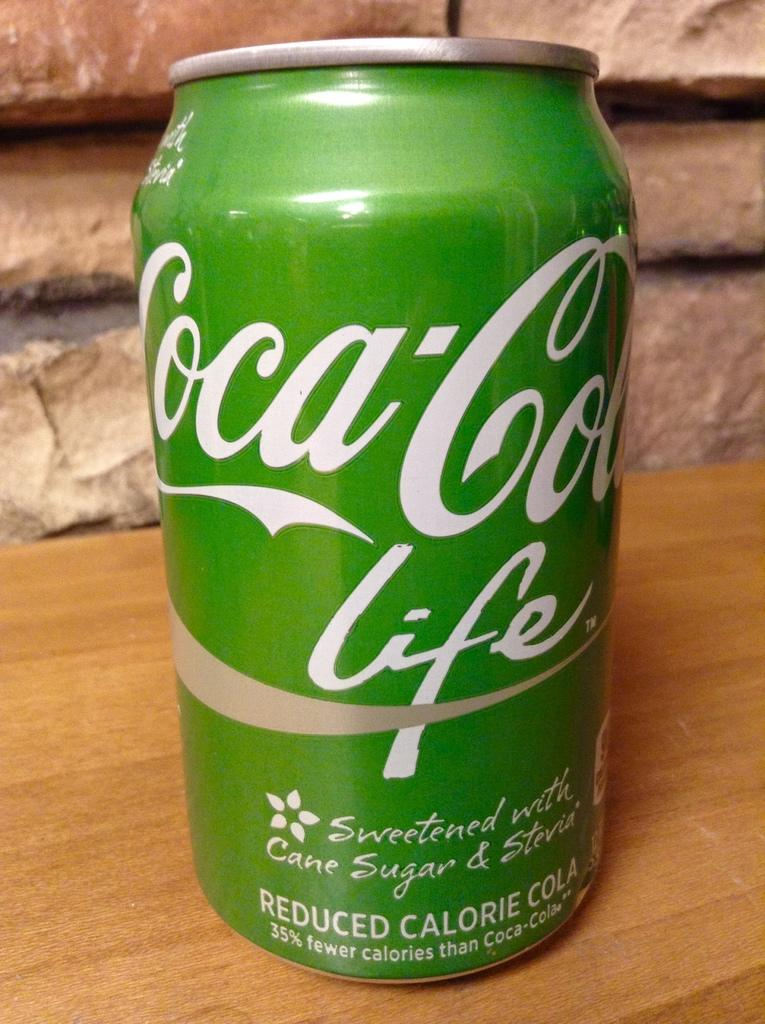What object is present in the picture? There is a tin in the picture. What color is the tin? The tin is green in color. What is written on the tin? The word "Coca Cola" is written on the tin. What can be seen in the background of the image? There is a brick wall in the background of the image. What type of glass is being used to cook the meal in the image? There is no glass or cooking activity present in the image; it features a green tin with the words "Coca Cola" written on it and a brick wall in the background. 